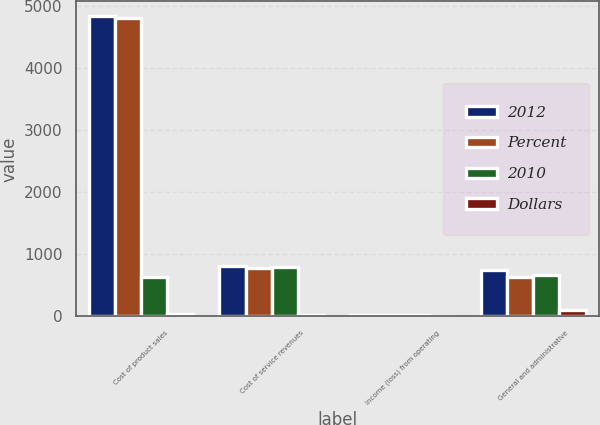Convert chart. <chart><loc_0><loc_0><loc_500><loc_500><stacked_bar_chart><ecel><fcel>Cost of product sales<fcel>Cost of service revenues<fcel>Income (loss) from operating<fcel>General and administrative<nl><fcel>2012<fcel>4827<fcel>802<fcel>18<fcel>739<nl><fcel>Percent<fcel>4794<fcel>777<fcel>20<fcel>634<nl><fcel>2010<fcel>634<fcel>789<fcel>19<fcel>670<nl><fcel>Dollars<fcel>33<fcel>25<fcel>2<fcel>105<nl></chart> 